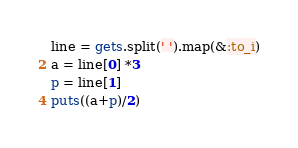Convert code to text. <code><loc_0><loc_0><loc_500><loc_500><_Ruby_>line = gets.split(' ').map(&:to_i)
a = line[0] *3
p = line[1]
puts((a+p)/2)</code> 